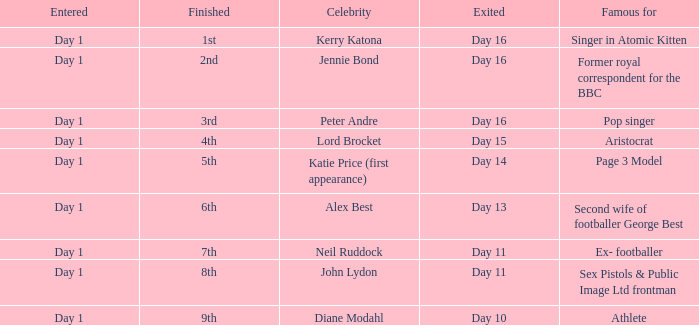Name who was famous for finished in 9th Athlete. 